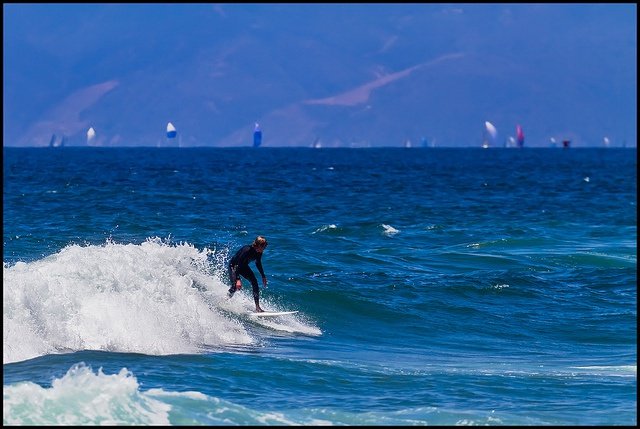Describe the objects in this image and their specific colors. I can see people in black, navy, gray, and blue tones, boat in black, blue, and darkgray tones, and surfboard in black, white, darkgray, and gray tones in this image. 